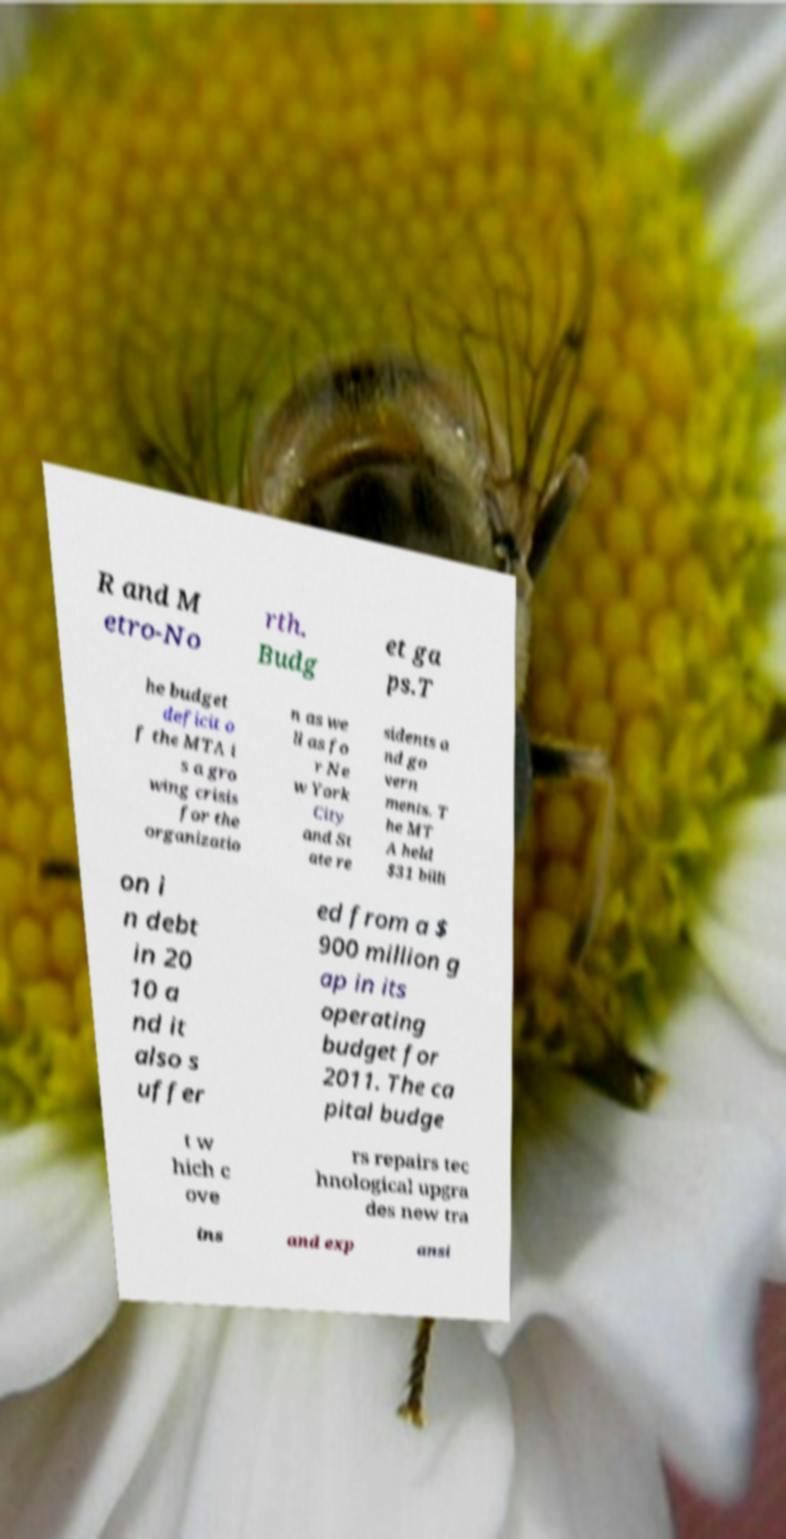Can you read and provide the text displayed in the image?This photo seems to have some interesting text. Can you extract and type it out for me? R and M etro-No rth. Budg et ga ps.T he budget deficit o f the MTA i s a gro wing crisis for the organizatio n as we ll as fo r Ne w York City and St ate re sidents a nd go vern ments. T he MT A held $31 billi on i n debt in 20 10 a nd it also s uffer ed from a $ 900 million g ap in its operating budget for 2011. The ca pital budge t w hich c ove rs repairs tec hnological upgra des new tra ins and exp ansi 